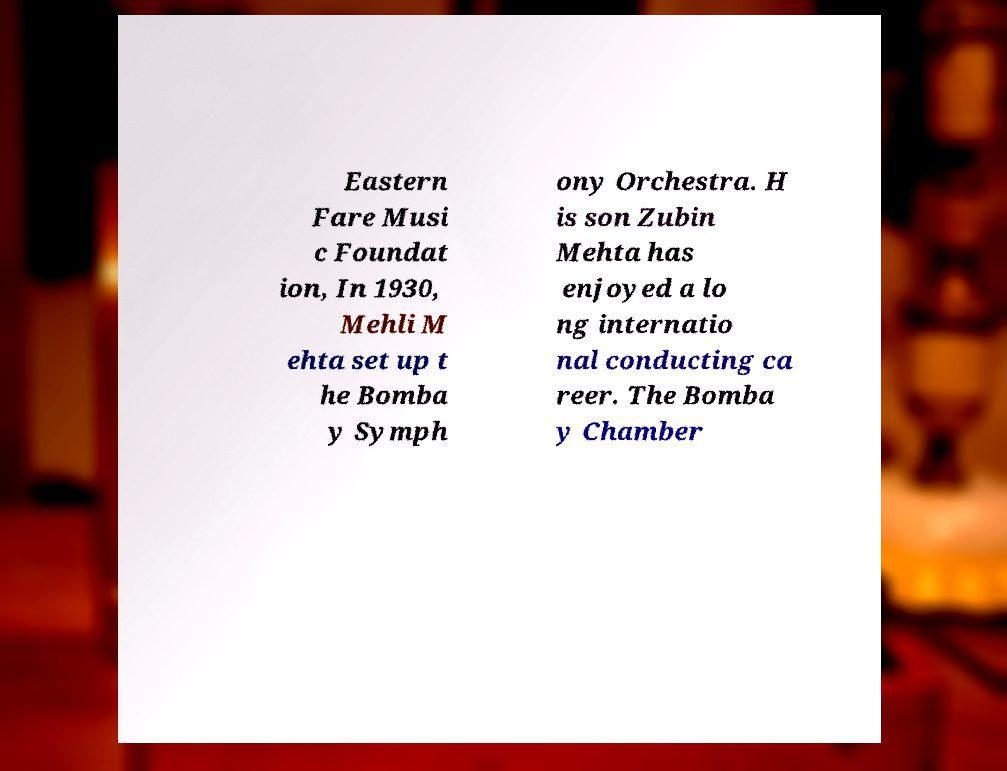There's text embedded in this image that I need extracted. Can you transcribe it verbatim? Eastern Fare Musi c Foundat ion, In 1930, Mehli M ehta set up t he Bomba y Symph ony Orchestra. H is son Zubin Mehta has enjoyed a lo ng internatio nal conducting ca reer. The Bomba y Chamber 